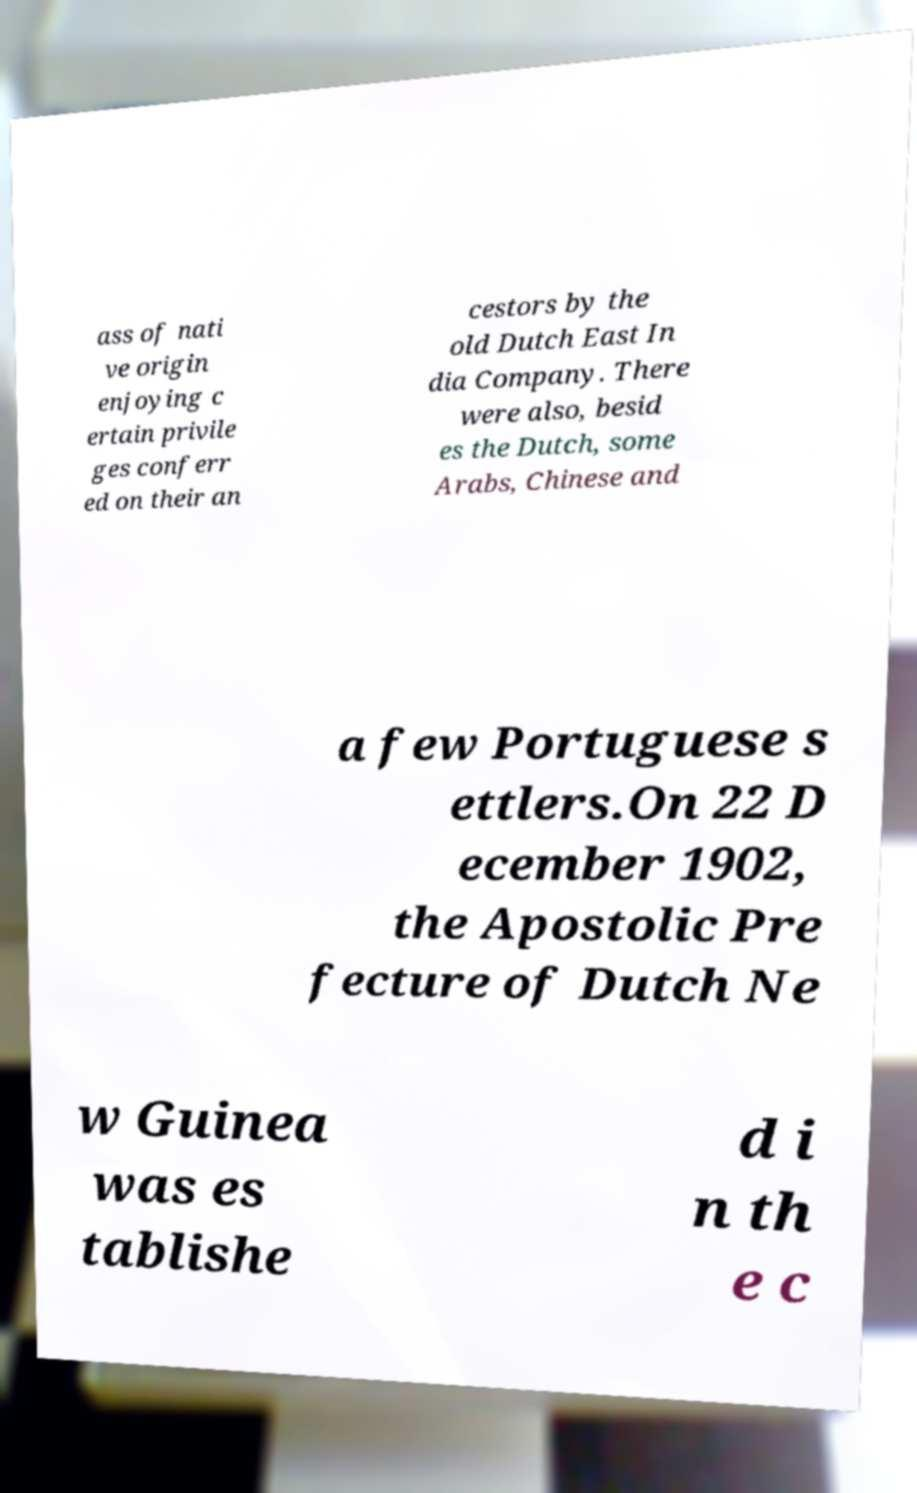For documentation purposes, I need the text within this image transcribed. Could you provide that? ass of nati ve origin enjoying c ertain privile ges conferr ed on their an cestors by the old Dutch East In dia Company. There were also, besid es the Dutch, some Arabs, Chinese and a few Portuguese s ettlers.On 22 D ecember 1902, the Apostolic Pre fecture of Dutch Ne w Guinea was es tablishe d i n th e c 